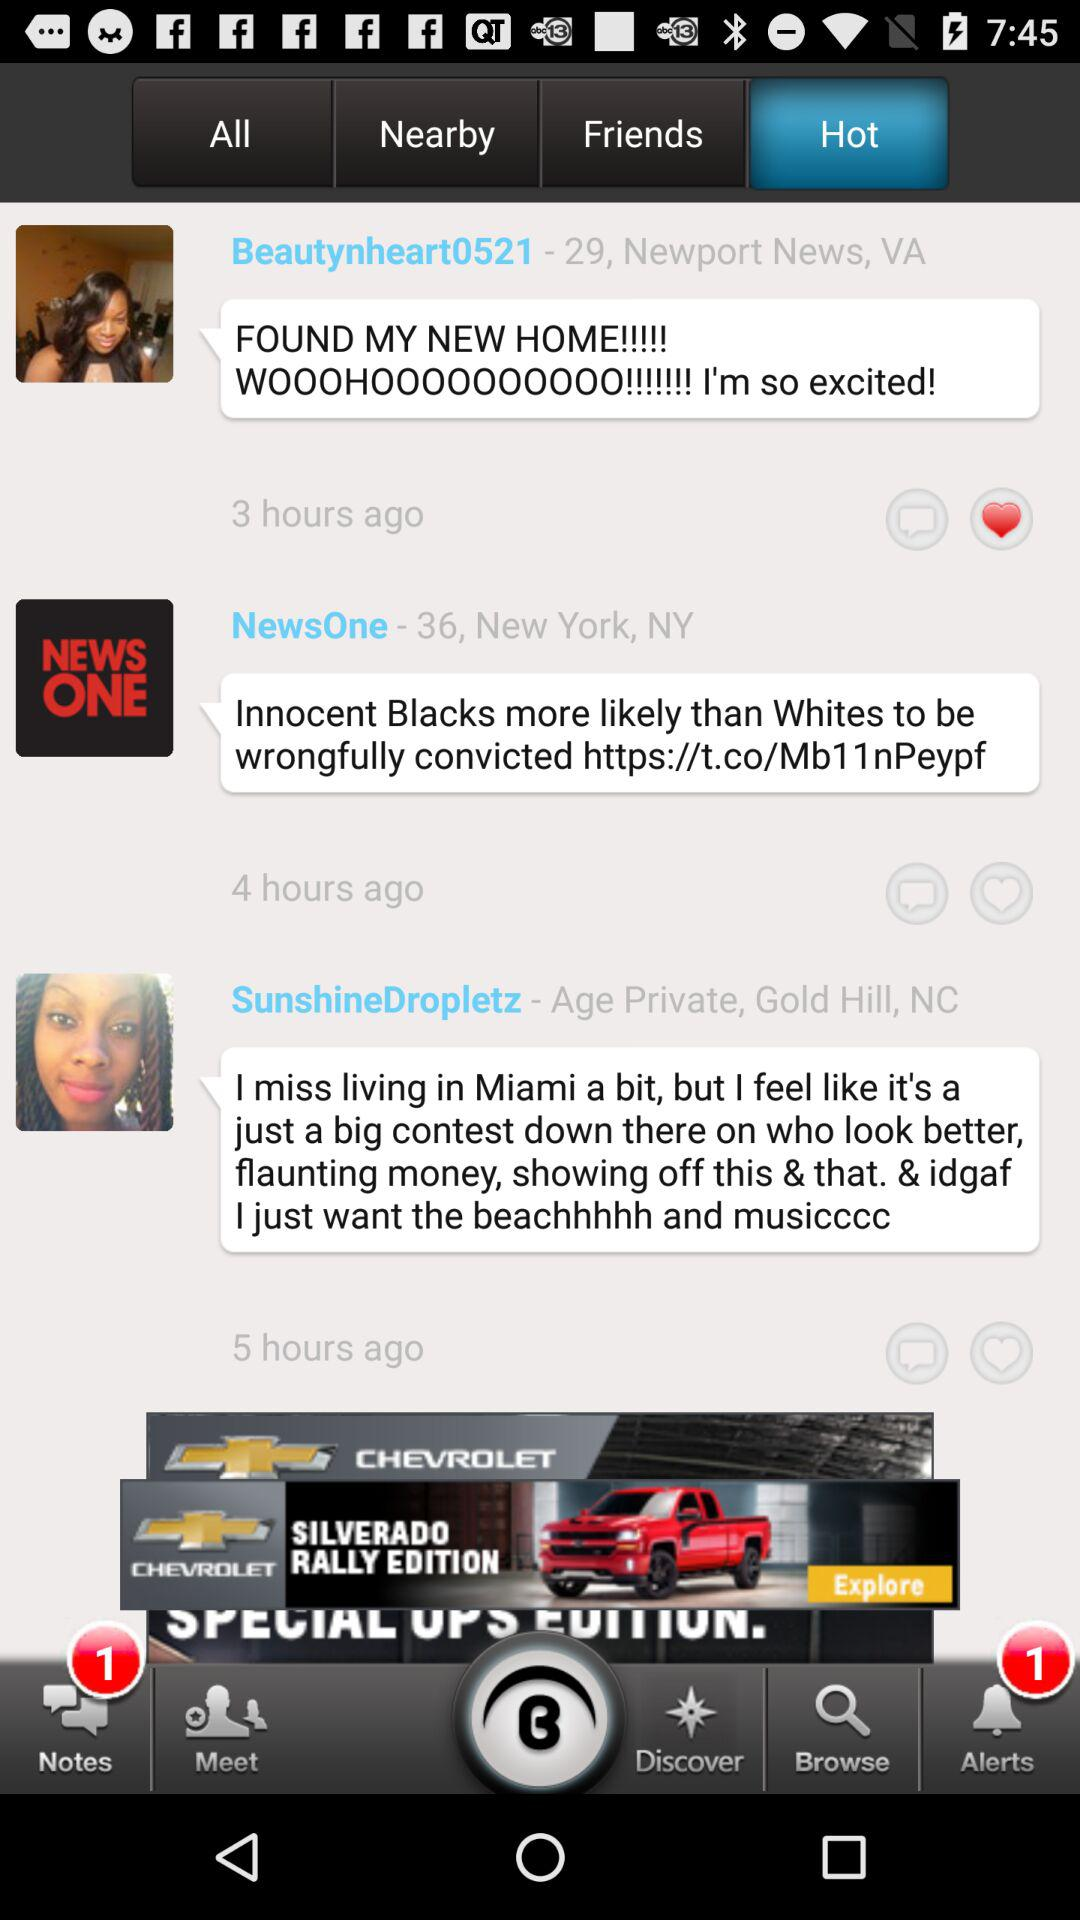Which tab is selected? The selected tab is "Hot". 